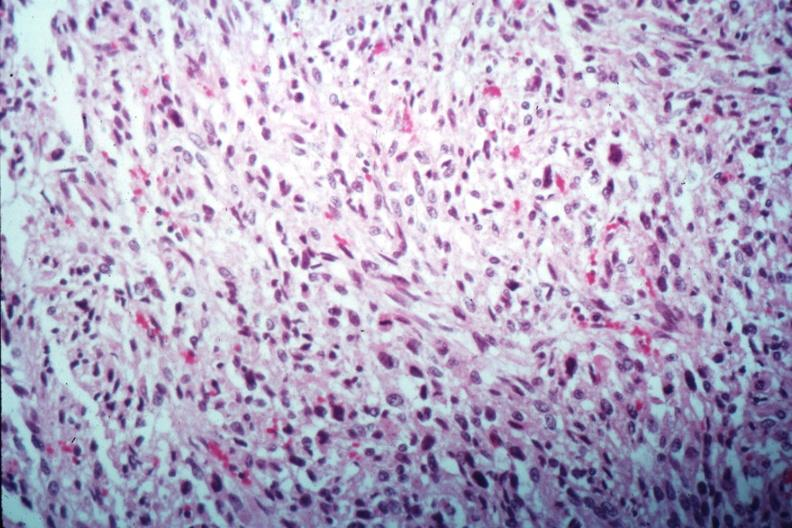what is present?
Answer the question using a single word or phrase. Leiomyosarcoma 